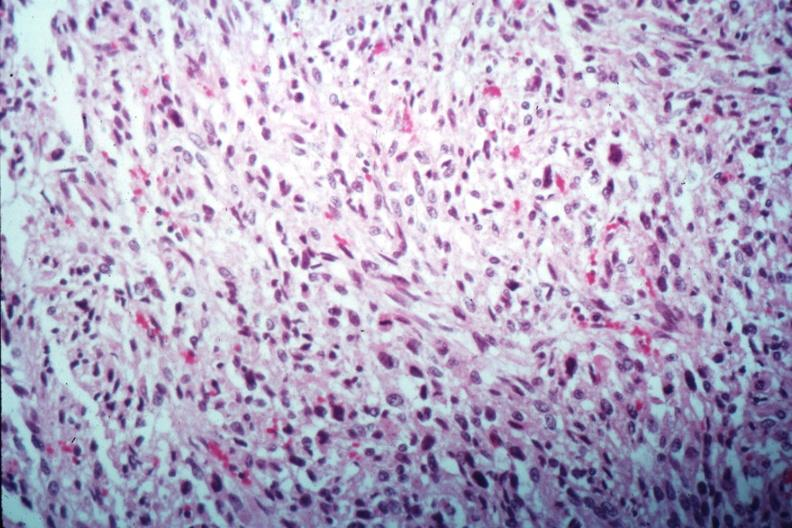what is present?
Answer the question using a single word or phrase. Leiomyosarcoma 